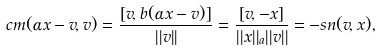Convert formula to latex. <formula><loc_0><loc_0><loc_500><loc_500>c m ( \alpha x - v , v ) = \frac { [ v , b ( \alpha x - v ) ] } { | | v | | } = \frac { [ v , - x ] } { | | x | | _ { a } | | v | | } = - s n ( v , x ) ,</formula> 